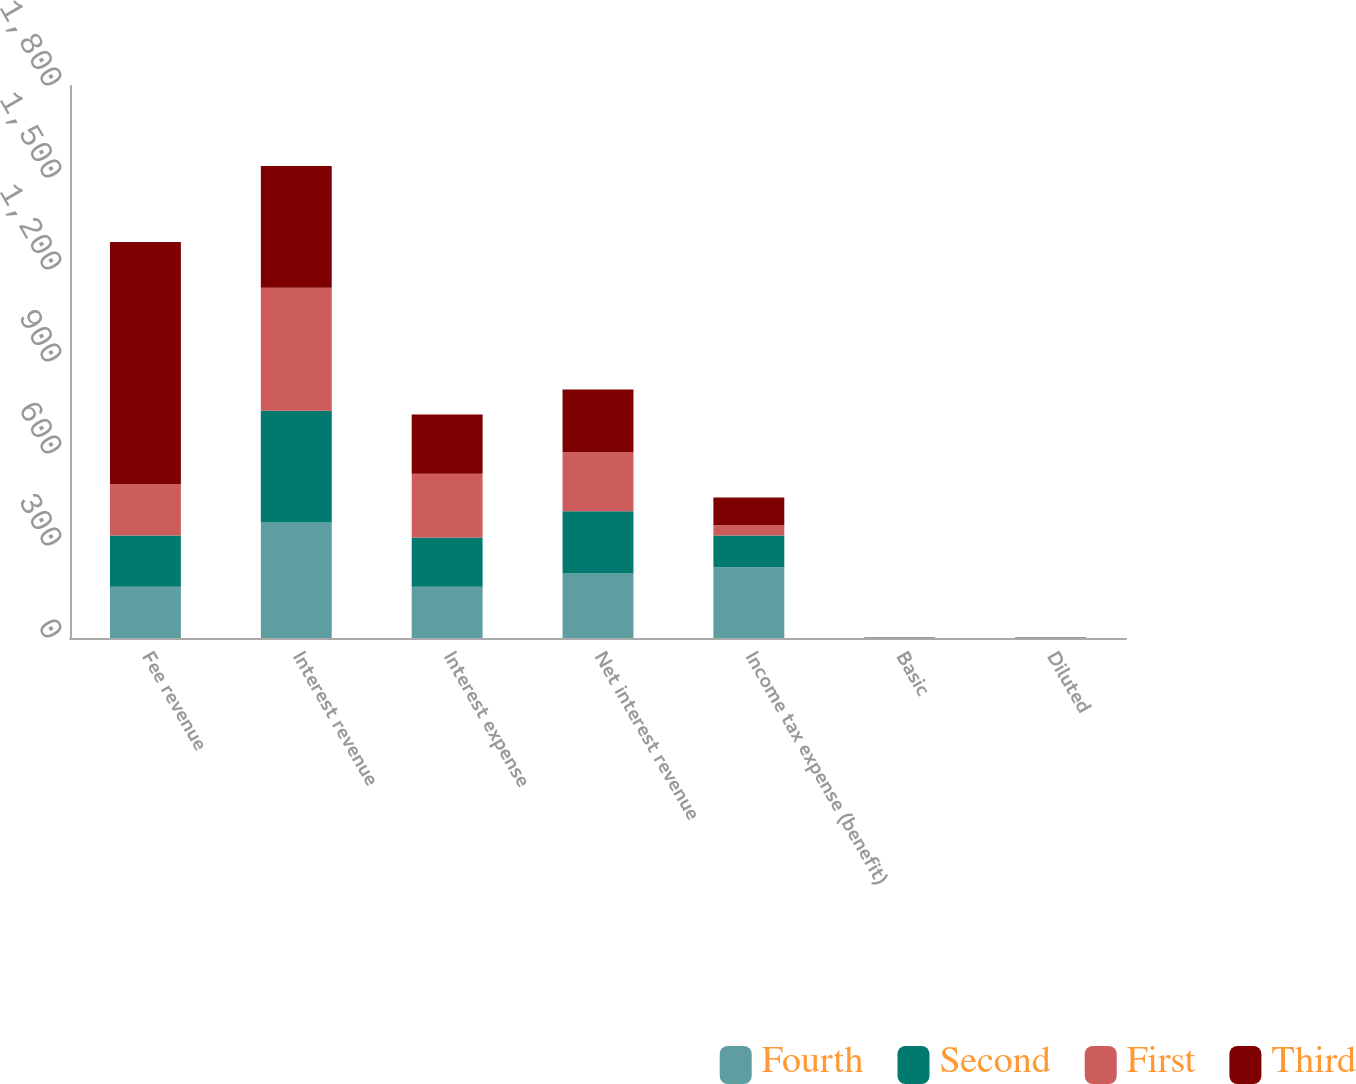Convert chart to OTSL. <chart><loc_0><loc_0><loc_500><loc_500><stacked_bar_chart><ecel><fcel>Fee revenue<fcel>Interest revenue<fcel>Interest expense<fcel>Net interest revenue<fcel>Income tax expense (benefit)<fcel>Basic<fcel>Diluted<nl><fcel>Fourth<fcel>167<fcel>377<fcel>167<fcel>210<fcel>231<fcel>1.34<fcel>1.33<nl><fcel>Second<fcel>167<fcel>364<fcel>161<fcel>203<fcel>103<fcel>0.61<fcel>0.6<nl><fcel>First<fcel>167<fcel>401<fcel>208<fcel>193<fcel>34<fcel>0.07<fcel>0.07<nl><fcel>Third<fcel>790<fcel>397<fcel>193<fcel>204<fcel>90<fcel>0.29<fcel>0.29<nl></chart> 